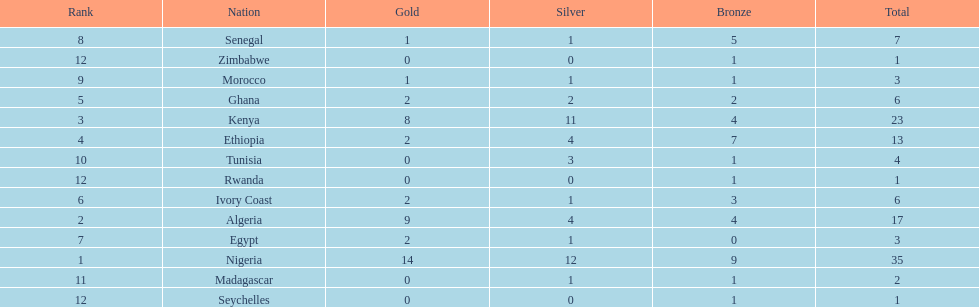What was the total number of medals the ivory coast won? 6. 